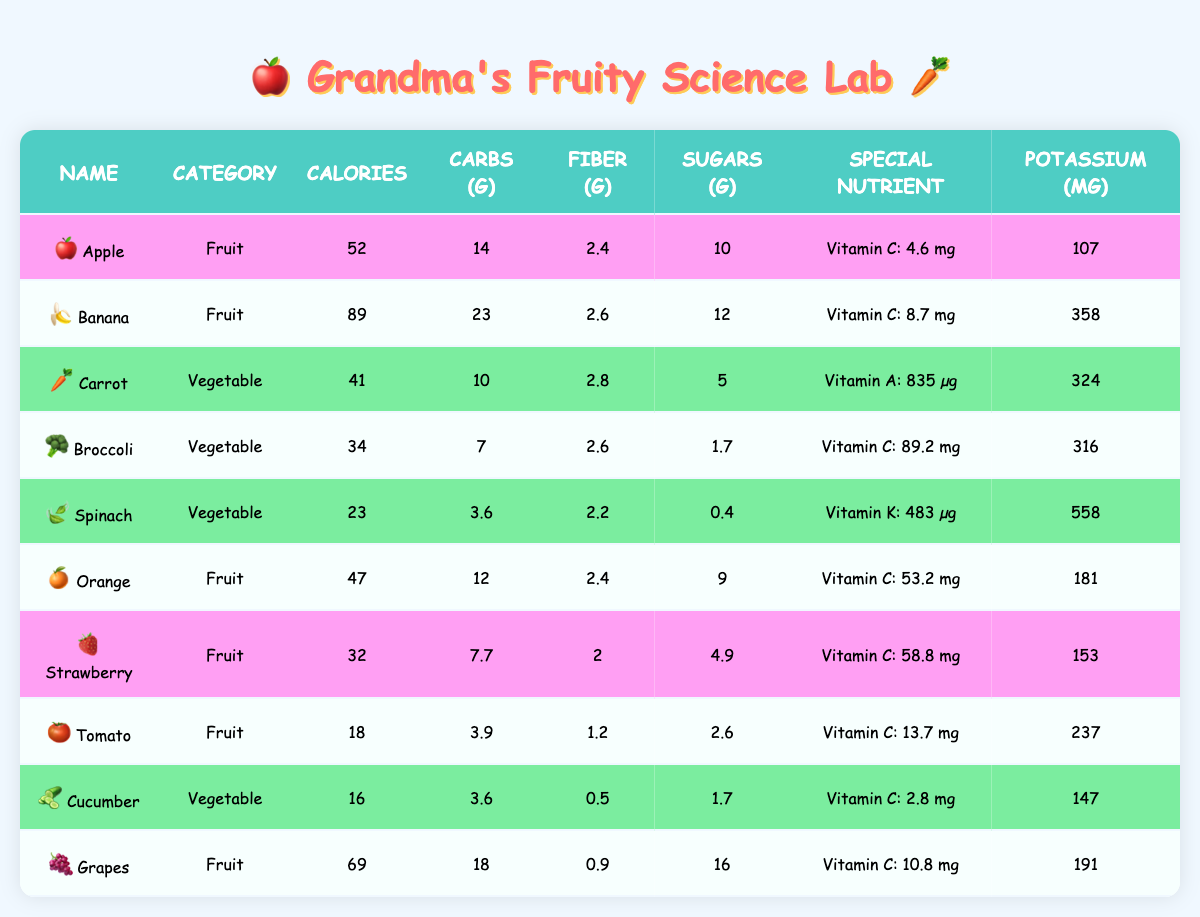What is the calorie content of a Banana? Looking at the table, the row for Banana shows that the calorie content is listed as 89 calories.
Answer: 89 calories Which fruit has the highest potassium content? By examining the potassium values of each fruit, we see that Banana has 358 mg, and other fruits like Apple has 107 mg, Orange has 181 mg, Strawberry has 153 mg, Tomato has 237 mg, and Grapes has 191 mg. The highest value among them is 358 mg for the Banana.
Answer: Banana What is the total fiber content of Carrot and Broccoli? From the Carrot row, the fiber content is 2.8 grams, and for Broccoli, it is 2.6 grams. Adding these two values together gives us 2.8 + 2.6 = 5.4 grams as the total fiber content for both vegetables.
Answer: 5.4 grams Is there more sugar in an Apple than in a Tomato? The table shows that Apple contains 10 grams of sugar, while Tomato has 2.6 grams. Since 10 is greater than 2.6, it confirms that Apple has more sugar than Tomato.
Answer: Yes What is the average calorie content of all the fruits listed? To find the average, we first sum the calories of all the fruits: Apple (52) + Banana (89) + Orange (47) + Strawberry (32) + Tomato (18) + Grapes (69) = 307 calories. There are 6 fruits, so we divide the total number of calories by the number of fruits: 307 / 6 = 51.1667. Rounding this gives us an average of approximately 51.17 calories.
Answer: 51.17 calories Which vegetable contains Vitamin K? Scanning the table, we see that Spinach is the only vegetable listed with a special nutrient, which is Vitamin K, at 483 micrograms.
Answer: Spinach How many grams of carbohydrates are in a Cucumber? The table indicates that the carbohydrate content for Cucumber is 3.6 grams, which can be found in its row.
Answer: 3.6 grams What is the sugar difference between Grapes and Strawberries? Grapes have 16 grams of sugar and Strawberries have 4.9 grams. We subtract the sugar content of Strawberries from Grapes: 16 - 4.9 = 11.1 grams, showing that Grapes contain 11.1 grams more sugar than Strawberries.
Answer: 11.1 grams How many different types of fruits are listed in this table? In the table, we count the unique fruits: Apple, Banana, Orange, Strawberry, Tomato, and Grapes. This gives us a total of 6 different types of fruits.
Answer: 6 fruits 